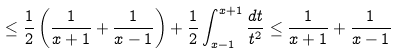<formula> <loc_0><loc_0><loc_500><loc_500>\leq \frac { 1 } { 2 } \left ( \frac { 1 } { x + 1 } + \frac { 1 } { x - 1 } \right ) + \frac { 1 } { 2 } \int _ { x - 1 } ^ { x + 1 } \frac { d t } { t ^ { 2 } } \leq \frac { 1 } { x + 1 } + \frac { 1 } { x - 1 }</formula> 